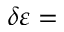Convert formula to latex. <formula><loc_0><loc_0><loc_500><loc_500>\delta \varepsilon =</formula> 